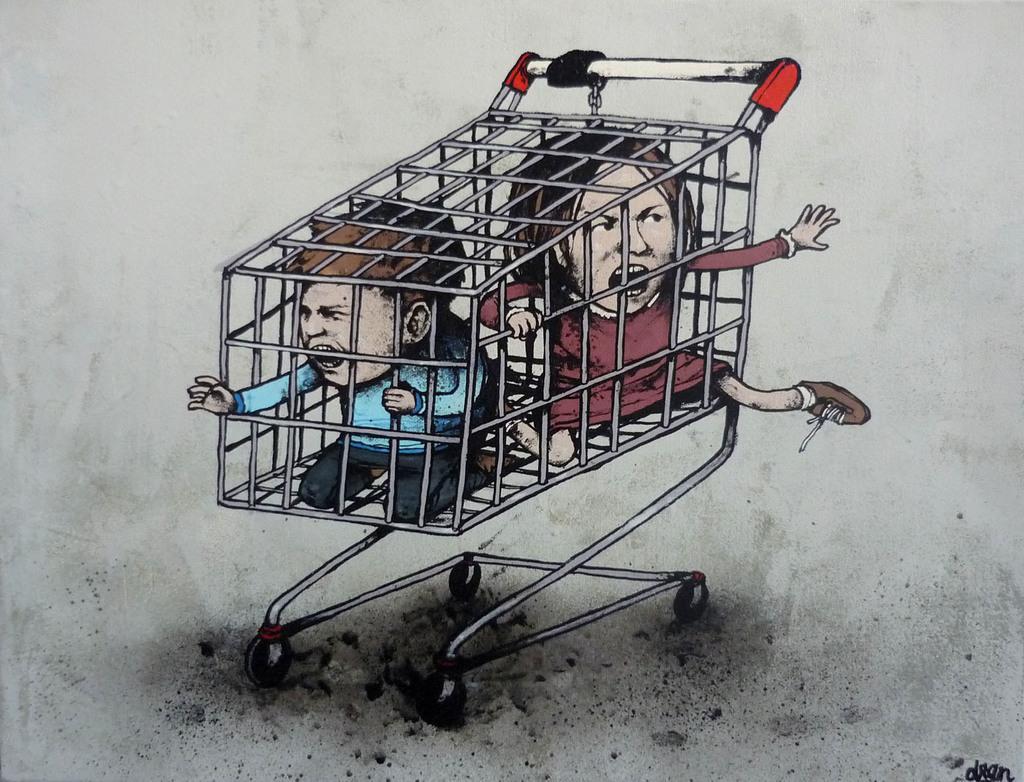Can you describe this image briefly? In this picture there is a painting. In the trolley there are two persons. On the right there is a woman who is wearing red dress and shoe. Beside her we can see a man who is wearing blue shirt, trouser and shoe. On the bottom right corner there is a watermark. 